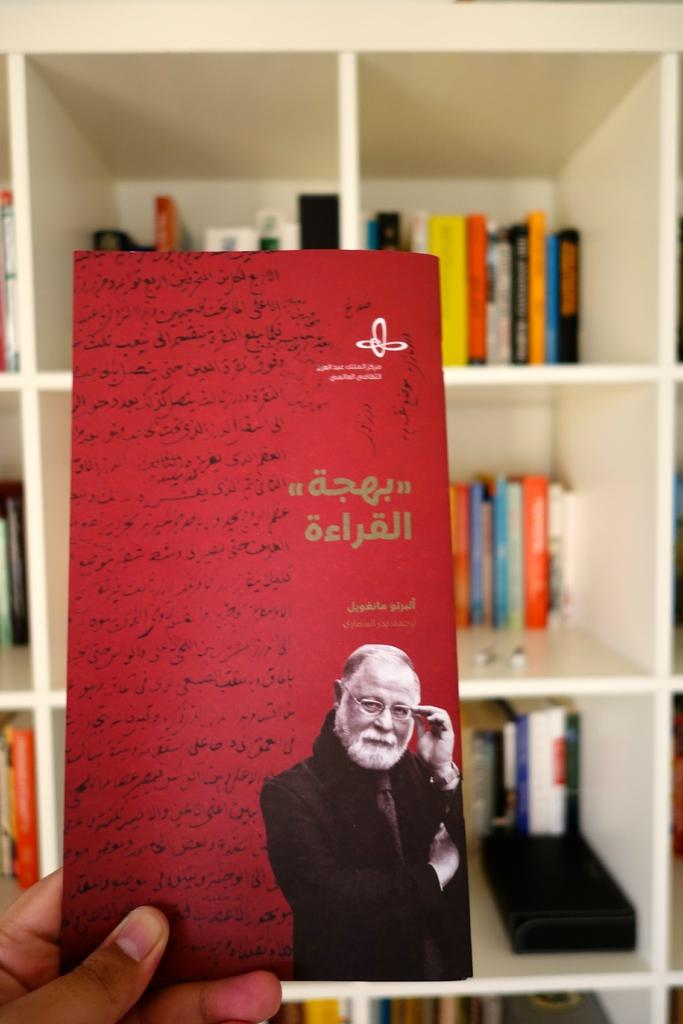What object is being held in the image? A person's hand is holding a card holder in the image. What is on the card inside the card holder? The card has a person and text on it. What can be seen in the background of the image? There are books in racks in the background of the image. Where is the vase located in the image? There is no vase present in the image. What type of food is being served in the image? There is no food present in the image. 